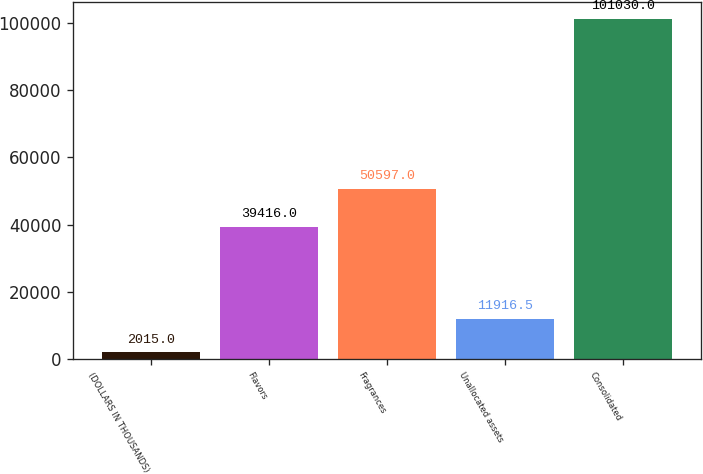Convert chart. <chart><loc_0><loc_0><loc_500><loc_500><bar_chart><fcel>(DOLLARS IN THOUSANDS)<fcel>Flavors<fcel>Fragrances<fcel>Unallocated assets<fcel>Consolidated<nl><fcel>2015<fcel>39416<fcel>50597<fcel>11916.5<fcel>101030<nl></chart> 